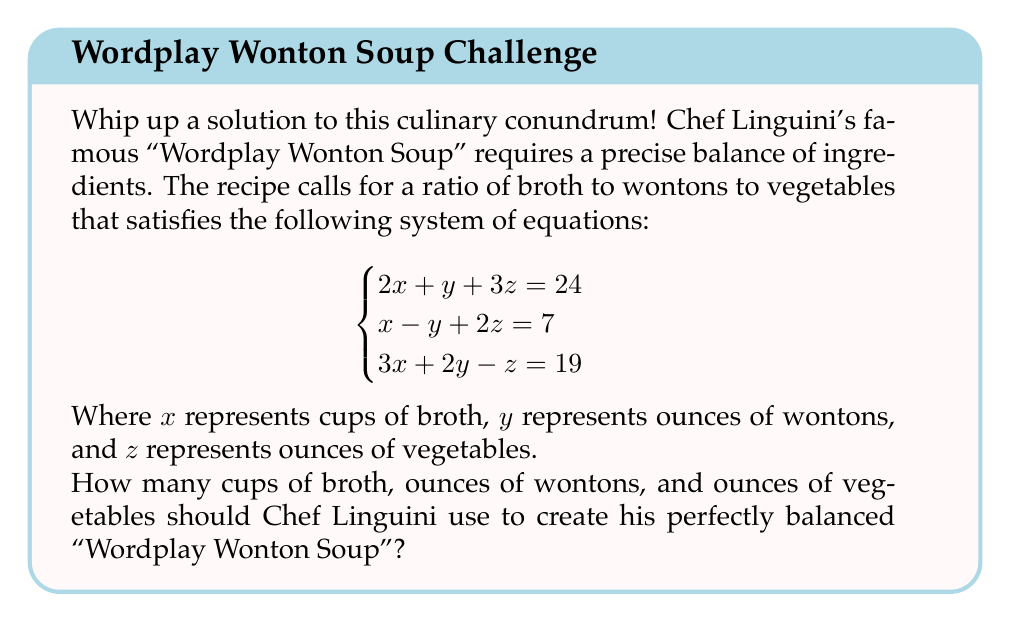Help me with this question. Let's solve this system of equations using the matrix method:

1) First, we'll write the augmented matrix:

   $$\begin{bmatrix}
   2 & 1 & 3 & | & 24 \\
   1 & -1 & 2 & | & 7 \\
   3 & 2 & -1 & | & 19
   \end{bmatrix}$$

2) Now, let's perform row operations to get the matrix in row echelon form:
   
   R2 → R2 - $\frac{1}{2}$R1:
   $$\begin{bmatrix}
   2 & 1 & 3 & | & 24 \\
   0 & -\frac{3}{2} & \frac{1}{2} & | & -5 \\
   3 & 2 & -1 & | & 19
   \end{bmatrix}$$

   R3 → R3 - $\frac{3}{2}$R1:
   $$\begin{bmatrix}
   2 & 1 & 3 & | & 24 \\
   0 & -\frac{3}{2} & \frac{1}{2} & | & -5 \\
   0 & \frac{1}{2} & -\frac{11}{2} & | & -17
   \end{bmatrix}$$

3) Continue row operations:
   
   R3 → R3 + $\frac{1}{3}$R2:
   $$\begin{bmatrix}
   2 & 1 & 3 & | & 24 \\
   0 & -\frac{3}{2} & \frac{1}{2} & | & -5 \\
   0 & 0 & -4 & | & -18
   \end{bmatrix}$$

4) Now we have the matrix in row echelon form. Let's solve for z, y, and x:

   From the last row: $-4z = -18$, so $z = \frac{18}{4} = \frac{9}{2}$

   From the second row: $-\frac{3}{2}y + \frac{1}{2}(\frac{9}{2}) = -5$
                        $-\frac{3}{2}y = -5 - \frac{9}{4} = -\frac{29}{4}$
                        $y = \frac{29}{6}$

   From the first row: $2x + \frac{29}{6} + 3(\frac{9}{2}) = 24$
                       $2x = 24 - \frac{29}{6} - \frac{27}{2} = \frac{33}{3}$
                       $x = \frac{11}{2}$

Therefore, Chef Linguini should use $\frac{11}{2}$ cups of broth, $\frac{29}{6}$ ounces of wontons, and $\frac{9}{2}$ ounces of vegetables.
Answer: $(\frac{11}{2}, \frac{29}{6}, \frac{9}{2})$ 